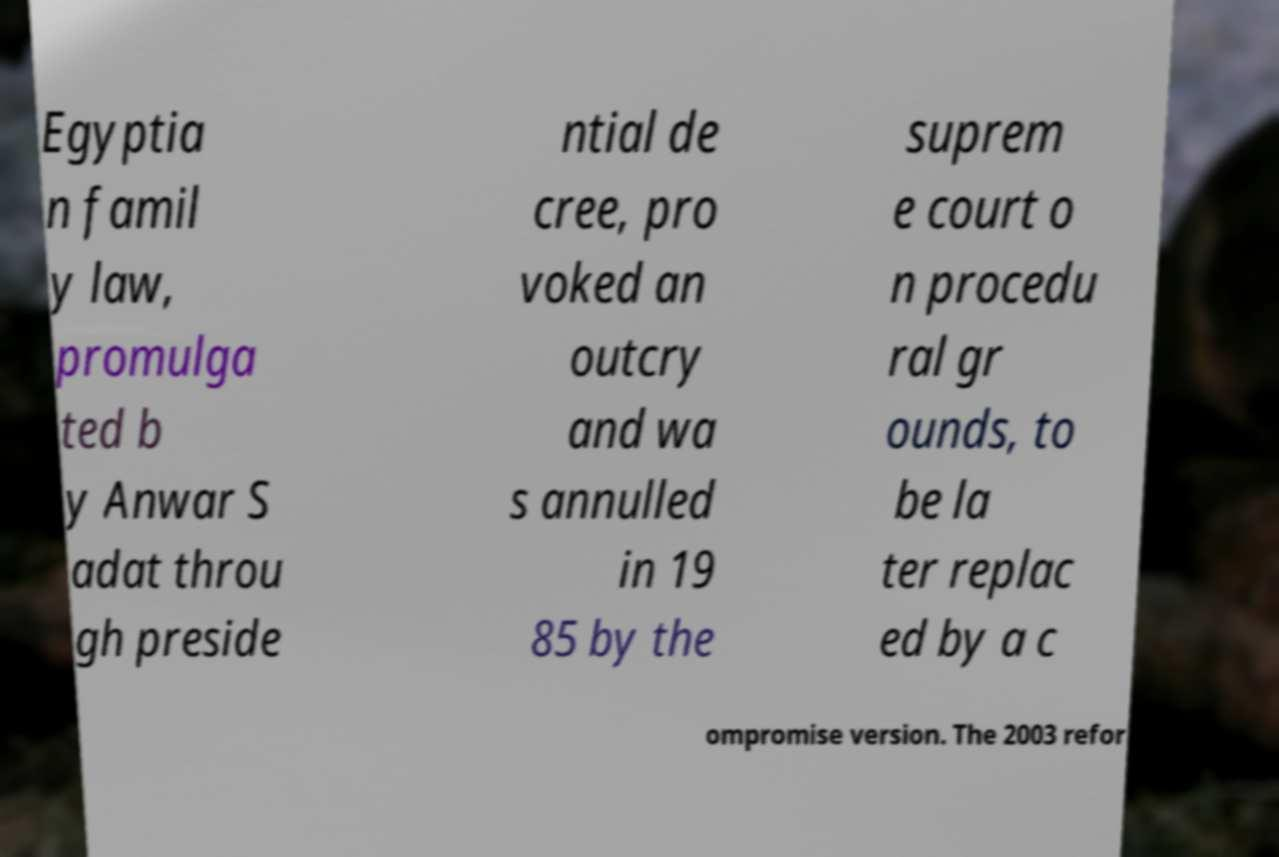Please read and relay the text visible in this image. What does it say? Egyptia n famil y law, promulga ted b y Anwar S adat throu gh preside ntial de cree, pro voked an outcry and wa s annulled in 19 85 by the suprem e court o n procedu ral gr ounds, to be la ter replac ed by a c ompromise version. The 2003 refor 